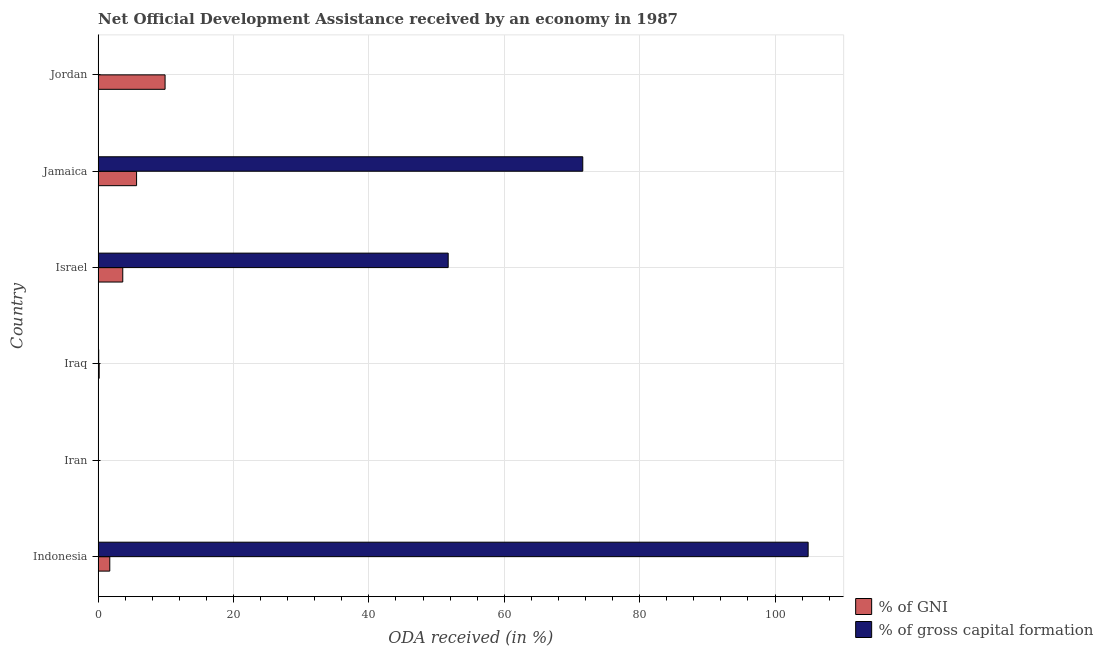Are the number of bars on each tick of the Y-axis equal?
Ensure brevity in your answer.  Yes. How many bars are there on the 4th tick from the top?
Provide a short and direct response. 2. How many bars are there on the 5th tick from the bottom?
Offer a very short reply. 2. What is the label of the 5th group of bars from the top?
Keep it short and to the point. Iran. In how many cases, is the number of bars for a given country not equal to the number of legend labels?
Keep it short and to the point. 0. What is the oda received as percentage of gross capital formation in Iraq?
Give a very brief answer. 0.09. Across all countries, what is the maximum oda received as percentage of gross capital formation?
Provide a succinct answer. 104.89. Across all countries, what is the minimum oda received as percentage of gni?
Ensure brevity in your answer.  0.05. In which country was the oda received as percentage of gni maximum?
Ensure brevity in your answer.  Jordan. In which country was the oda received as percentage of gni minimum?
Offer a very short reply. Iran. What is the total oda received as percentage of gni in the graph?
Your response must be concise. 21.15. What is the difference between the oda received as percentage of gni in Iran and that in Israel?
Make the answer very short. -3.59. What is the difference between the oda received as percentage of gni in Indonesia and the oda received as percentage of gross capital formation in Iraq?
Make the answer very short. 1.64. What is the average oda received as percentage of gross capital formation per country?
Offer a terse response. 38.06. What is the difference between the oda received as percentage of gni and oda received as percentage of gross capital formation in Jordan?
Keep it short and to the point. 9.86. In how many countries, is the oda received as percentage of gross capital formation greater than 100 %?
Provide a short and direct response. 1. What is the ratio of the oda received as percentage of gni in Iraq to that in Jordan?
Give a very brief answer. 0.02. Is the difference between the oda received as percentage of gross capital formation in Indonesia and Jamaica greater than the difference between the oda received as percentage of gni in Indonesia and Jamaica?
Keep it short and to the point. Yes. What is the difference between the highest and the second highest oda received as percentage of gross capital formation?
Give a very brief answer. 33.29. What is the difference between the highest and the lowest oda received as percentage of gni?
Make the answer very short. 9.84. In how many countries, is the oda received as percentage of gross capital formation greater than the average oda received as percentage of gross capital formation taken over all countries?
Your answer should be compact. 3. What does the 1st bar from the top in Iraq represents?
Offer a terse response. % of gross capital formation. What does the 2nd bar from the bottom in Israel represents?
Offer a terse response. % of gross capital formation. How many countries are there in the graph?
Ensure brevity in your answer.  6. What is the difference between two consecutive major ticks on the X-axis?
Ensure brevity in your answer.  20. Does the graph contain any zero values?
Your answer should be very brief. No. What is the title of the graph?
Keep it short and to the point. Net Official Development Assistance received by an economy in 1987. What is the label or title of the X-axis?
Keep it short and to the point. ODA received (in %). What is the label or title of the Y-axis?
Your answer should be compact. Country. What is the ODA received (in %) of % of GNI in Indonesia?
Your response must be concise. 1.72. What is the ODA received (in %) in % of gross capital formation in Indonesia?
Your response must be concise. 104.89. What is the ODA received (in %) in % of GNI in Iran?
Provide a succinct answer. 0.05. What is the ODA received (in %) of % of gross capital formation in Iran?
Make the answer very short. 0.03. What is the ODA received (in %) of % of GNI in Iraq?
Offer a terse response. 0.16. What is the ODA received (in %) of % of gross capital formation in Iraq?
Offer a very short reply. 0.09. What is the ODA received (in %) in % of GNI in Israel?
Your answer should be compact. 3.64. What is the ODA received (in %) in % of gross capital formation in Israel?
Offer a very short reply. 51.71. What is the ODA received (in %) in % of GNI in Jamaica?
Offer a terse response. 5.68. What is the ODA received (in %) in % of gross capital formation in Jamaica?
Provide a succinct answer. 71.59. What is the ODA received (in %) in % of GNI in Jordan?
Your response must be concise. 9.89. What is the ODA received (in %) of % of gross capital formation in Jordan?
Offer a very short reply. 0.03. Across all countries, what is the maximum ODA received (in %) in % of GNI?
Your response must be concise. 9.89. Across all countries, what is the maximum ODA received (in %) of % of gross capital formation?
Make the answer very short. 104.89. Across all countries, what is the minimum ODA received (in %) in % of GNI?
Provide a succinct answer. 0.05. Across all countries, what is the minimum ODA received (in %) in % of gross capital formation?
Offer a very short reply. 0.03. What is the total ODA received (in %) of % of GNI in the graph?
Your answer should be very brief. 21.15. What is the total ODA received (in %) in % of gross capital formation in the graph?
Your answer should be very brief. 228.33. What is the difference between the ODA received (in %) of % of GNI in Indonesia and that in Iran?
Provide a short and direct response. 1.67. What is the difference between the ODA received (in %) of % of gross capital formation in Indonesia and that in Iran?
Make the answer very short. 104.86. What is the difference between the ODA received (in %) in % of GNI in Indonesia and that in Iraq?
Provide a short and direct response. 1.56. What is the difference between the ODA received (in %) in % of gross capital formation in Indonesia and that in Iraq?
Give a very brief answer. 104.8. What is the difference between the ODA received (in %) of % of GNI in Indonesia and that in Israel?
Provide a succinct answer. -1.92. What is the difference between the ODA received (in %) of % of gross capital formation in Indonesia and that in Israel?
Offer a very short reply. 53.17. What is the difference between the ODA received (in %) of % of GNI in Indonesia and that in Jamaica?
Offer a very short reply. -3.96. What is the difference between the ODA received (in %) of % of gross capital formation in Indonesia and that in Jamaica?
Provide a succinct answer. 33.29. What is the difference between the ODA received (in %) of % of GNI in Indonesia and that in Jordan?
Keep it short and to the point. -8.17. What is the difference between the ODA received (in %) in % of gross capital formation in Indonesia and that in Jordan?
Offer a terse response. 104.86. What is the difference between the ODA received (in %) in % of GNI in Iran and that in Iraq?
Your response must be concise. -0.11. What is the difference between the ODA received (in %) in % of gross capital formation in Iran and that in Iraq?
Your answer should be compact. -0.06. What is the difference between the ODA received (in %) in % of GNI in Iran and that in Israel?
Offer a very short reply. -3.59. What is the difference between the ODA received (in %) of % of gross capital formation in Iran and that in Israel?
Make the answer very short. -51.69. What is the difference between the ODA received (in %) of % of GNI in Iran and that in Jamaica?
Give a very brief answer. -5.63. What is the difference between the ODA received (in %) of % of gross capital formation in Iran and that in Jamaica?
Offer a terse response. -71.57. What is the difference between the ODA received (in %) in % of GNI in Iran and that in Jordan?
Make the answer very short. -9.84. What is the difference between the ODA received (in %) of % of gross capital formation in Iran and that in Jordan?
Your response must be concise. -0. What is the difference between the ODA received (in %) in % of GNI in Iraq and that in Israel?
Offer a terse response. -3.48. What is the difference between the ODA received (in %) in % of gross capital formation in Iraq and that in Israel?
Ensure brevity in your answer.  -51.63. What is the difference between the ODA received (in %) in % of GNI in Iraq and that in Jamaica?
Your answer should be compact. -5.52. What is the difference between the ODA received (in %) in % of gross capital formation in Iraq and that in Jamaica?
Ensure brevity in your answer.  -71.51. What is the difference between the ODA received (in %) in % of GNI in Iraq and that in Jordan?
Provide a short and direct response. -9.73. What is the difference between the ODA received (in %) of % of gross capital formation in Iraq and that in Jordan?
Provide a succinct answer. 0.06. What is the difference between the ODA received (in %) of % of GNI in Israel and that in Jamaica?
Offer a terse response. -2.04. What is the difference between the ODA received (in %) of % of gross capital formation in Israel and that in Jamaica?
Give a very brief answer. -19.88. What is the difference between the ODA received (in %) in % of GNI in Israel and that in Jordan?
Your answer should be compact. -6.25. What is the difference between the ODA received (in %) of % of gross capital formation in Israel and that in Jordan?
Your answer should be compact. 51.69. What is the difference between the ODA received (in %) of % of GNI in Jamaica and that in Jordan?
Provide a short and direct response. -4.21. What is the difference between the ODA received (in %) of % of gross capital formation in Jamaica and that in Jordan?
Keep it short and to the point. 71.56. What is the difference between the ODA received (in %) in % of GNI in Indonesia and the ODA received (in %) in % of gross capital formation in Iran?
Ensure brevity in your answer.  1.7. What is the difference between the ODA received (in %) in % of GNI in Indonesia and the ODA received (in %) in % of gross capital formation in Iraq?
Make the answer very short. 1.64. What is the difference between the ODA received (in %) of % of GNI in Indonesia and the ODA received (in %) of % of gross capital formation in Israel?
Keep it short and to the point. -49.99. What is the difference between the ODA received (in %) of % of GNI in Indonesia and the ODA received (in %) of % of gross capital formation in Jamaica?
Your answer should be very brief. -69.87. What is the difference between the ODA received (in %) in % of GNI in Indonesia and the ODA received (in %) in % of gross capital formation in Jordan?
Ensure brevity in your answer.  1.7. What is the difference between the ODA received (in %) in % of GNI in Iran and the ODA received (in %) in % of gross capital formation in Iraq?
Provide a short and direct response. -0.03. What is the difference between the ODA received (in %) of % of GNI in Iran and the ODA received (in %) of % of gross capital formation in Israel?
Offer a very short reply. -51.66. What is the difference between the ODA received (in %) of % of GNI in Iran and the ODA received (in %) of % of gross capital formation in Jamaica?
Your answer should be very brief. -71.54. What is the difference between the ODA received (in %) in % of GNI in Iran and the ODA received (in %) in % of gross capital formation in Jordan?
Give a very brief answer. 0.02. What is the difference between the ODA received (in %) in % of GNI in Iraq and the ODA received (in %) in % of gross capital formation in Israel?
Make the answer very short. -51.55. What is the difference between the ODA received (in %) of % of GNI in Iraq and the ODA received (in %) of % of gross capital formation in Jamaica?
Your answer should be compact. -71.43. What is the difference between the ODA received (in %) of % of GNI in Iraq and the ODA received (in %) of % of gross capital formation in Jordan?
Make the answer very short. 0.13. What is the difference between the ODA received (in %) in % of GNI in Israel and the ODA received (in %) in % of gross capital formation in Jamaica?
Your answer should be compact. -67.95. What is the difference between the ODA received (in %) in % of GNI in Israel and the ODA received (in %) in % of gross capital formation in Jordan?
Ensure brevity in your answer.  3.61. What is the difference between the ODA received (in %) of % of GNI in Jamaica and the ODA received (in %) of % of gross capital formation in Jordan?
Ensure brevity in your answer.  5.65. What is the average ODA received (in %) in % of GNI per country?
Offer a terse response. 3.52. What is the average ODA received (in %) of % of gross capital formation per country?
Provide a short and direct response. 38.06. What is the difference between the ODA received (in %) in % of GNI and ODA received (in %) in % of gross capital formation in Indonesia?
Offer a terse response. -103.16. What is the difference between the ODA received (in %) in % of GNI and ODA received (in %) in % of gross capital formation in Iran?
Keep it short and to the point. 0.03. What is the difference between the ODA received (in %) in % of GNI and ODA received (in %) in % of gross capital formation in Iraq?
Give a very brief answer. 0.07. What is the difference between the ODA received (in %) of % of GNI and ODA received (in %) of % of gross capital formation in Israel?
Ensure brevity in your answer.  -48.07. What is the difference between the ODA received (in %) in % of GNI and ODA received (in %) in % of gross capital formation in Jamaica?
Provide a short and direct response. -65.91. What is the difference between the ODA received (in %) of % of GNI and ODA received (in %) of % of gross capital formation in Jordan?
Your answer should be compact. 9.86. What is the ratio of the ODA received (in %) of % of GNI in Indonesia to that in Iran?
Provide a succinct answer. 33.51. What is the ratio of the ODA received (in %) in % of gross capital formation in Indonesia to that in Iran?
Give a very brief answer. 4139.05. What is the ratio of the ODA received (in %) in % of GNI in Indonesia to that in Iraq?
Your answer should be compact. 10.85. What is the ratio of the ODA received (in %) of % of gross capital formation in Indonesia to that in Iraq?
Your answer should be very brief. 1214.22. What is the ratio of the ODA received (in %) of % of GNI in Indonesia to that in Israel?
Your answer should be very brief. 0.47. What is the ratio of the ODA received (in %) in % of gross capital formation in Indonesia to that in Israel?
Your answer should be very brief. 2.03. What is the ratio of the ODA received (in %) in % of GNI in Indonesia to that in Jamaica?
Provide a short and direct response. 0.3. What is the ratio of the ODA received (in %) of % of gross capital formation in Indonesia to that in Jamaica?
Your response must be concise. 1.47. What is the ratio of the ODA received (in %) of % of GNI in Indonesia to that in Jordan?
Provide a succinct answer. 0.17. What is the ratio of the ODA received (in %) of % of gross capital formation in Indonesia to that in Jordan?
Ensure brevity in your answer.  3669.01. What is the ratio of the ODA received (in %) of % of GNI in Iran to that in Iraq?
Your answer should be very brief. 0.32. What is the ratio of the ODA received (in %) of % of gross capital formation in Iran to that in Iraq?
Offer a terse response. 0.29. What is the ratio of the ODA received (in %) in % of GNI in Iran to that in Israel?
Your answer should be very brief. 0.01. What is the ratio of the ODA received (in %) of % of GNI in Iran to that in Jamaica?
Provide a short and direct response. 0.01. What is the ratio of the ODA received (in %) of % of gross capital formation in Iran to that in Jamaica?
Ensure brevity in your answer.  0. What is the ratio of the ODA received (in %) of % of GNI in Iran to that in Jordan?
Your response must be concise. 0.01. What is the ratio of the ODA received (in %) in % of gross capital formation in Iran to that in Jordan?
Your answer should be compact. 0.89. What is the ratio of the ODA received (in %) of % of GNI in Iraq to that in Israel?
Ensure brevity in your answer.  0.04. What is the ratio of the ODA received (in %) of % of gross capital formation in Iraq to that in Israel?
Your answer should be compact. 0. What is the ratio of the ODA received (in %) of % of GNI in Iraq to that in Jamaica?
Make the answer very short. 0.03. What is the ratio of the ODA received (in %) in % of gross capital formation in Iraq to that in Jamaica?
Offer a very short reply. 0. What is the ratio of the ODA received (in %) of % of GNI in Iraq to that in Jordan?
Provide a short and direct response. 0.02. What is the ratio of the ODA received (in %) of % of gross capital formation in Iraq to that in Jordan?
Provide a short and direct response. 3.02. What is the ratio of the ODA received (in %) of % of GNI in Israel to that in Jamaica?
Provide a succinct answer. 0.64. What is the ratio of the ODA received (in %) of % of gross capital formation in Israel to that in Jamaica?
Your answer should be very brief. 0.72. What is the ratio of the ODA received (in %) of % of GNI in Israel to that in Jordan?
Offer a very short reply. 0.37. What is the ratio of the ODA received (in %) of % of gross capital formation in Israel to that in Jordan?
Provide a succinct answer. 1808.98. What is the ratio of the ODA received (in %) in % of GNI in Jamaica to that in Jordan?
Offer a terse response. 0.57. What is the ratio of the ODA received (in %) of % of gross capital formation in Jamaica to that in Jordan?
Your answer should be very brief. 2504.37. What is the difference between the highest and the second highest ODA received (in %) in % of GNI?
Offer a very short reply. 4.21. What is the difference between the highest and the second highest ODA received (in %) of % of gross capital formation?
Provide a succinct answer. 33.29. What is the difference between the highest and the lowest ODA received (in %) in % of GNI?
Your answer should be compact. 9.84. What is the difference between the highest and the lowest ODA received (in %) in % of gross capital formation?
Your answer should be compact. 104.86. 